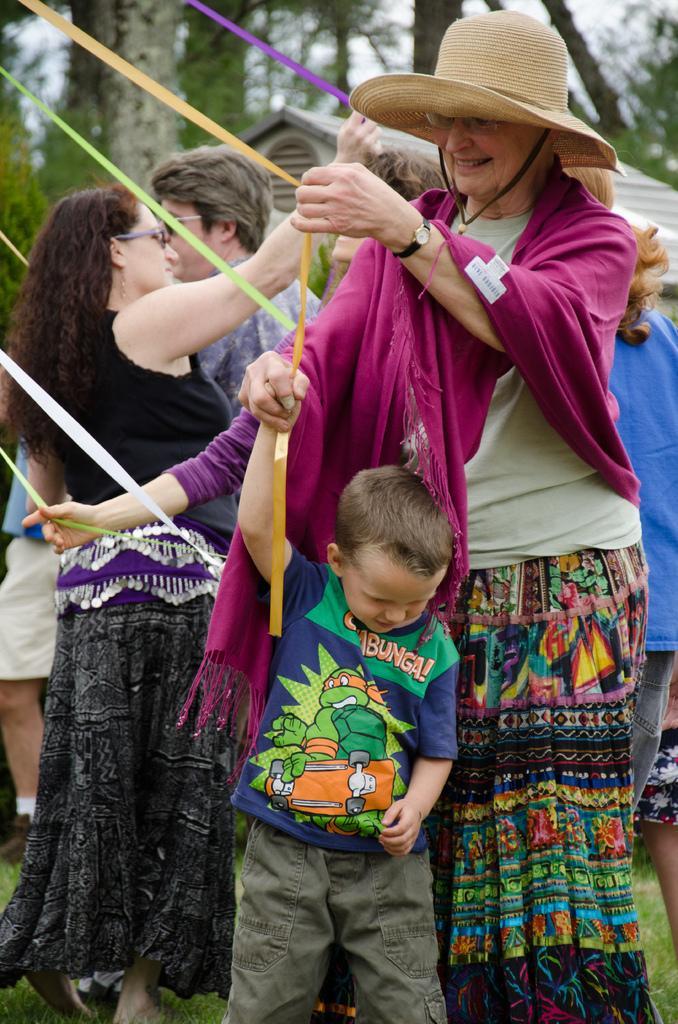Can you describe this image briefly? In this picture we can observe a woman wearing a cream color hat on her head and smiling. In front of her there is a boy standing, holding an orange color ribbon. In the background there are some people standing and holding ribbons of different colors. We can observe trees and sky here. 